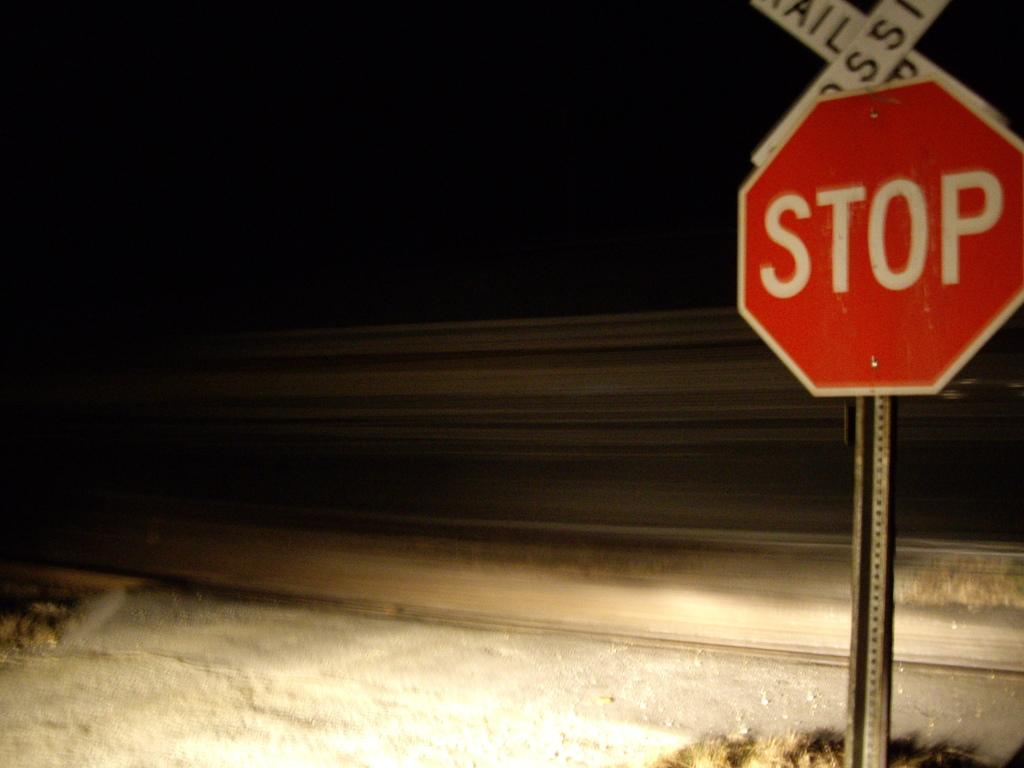<image>
Render a clear and concise summary of the photo. A railroad crossing sign sits atop a traditional red stop sign. 